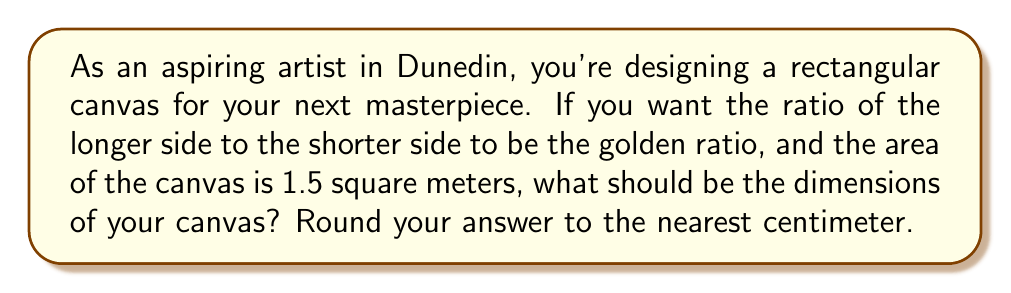Solve this math problem. Let's approach this step-by-step:

1) The golden ratio, often denoted by φ (phi), is approximately 1.618034. We'll use this value in our calculations.

2) Let's denote the shorter side of the rectangle as x and the longer side as y.

3) According to the golden ratio, we have:
   $$\frac{y}{x} = φ ≈ 1.618034$$

4) We can express y in terms of x:
   $$y = 1.618034x$$

5) We're given that the area of the canvas is 1.5 square meters. The area of a rectangle is length times width, so:
   $$xy = 1.5$$

6) Substituting the expression for y:
   $$x(1.618034x) = 1.5$$
   $$1.618034x^2 = 1.5$$

7) Solving for x:
   $$x^2 = \frac{1.5}{1.618034} ≈ 0.927178$$
   $$x ≈ \sqrt{0.927178} ≈ 0.962900$$

8) Now we can calculate y:
   $$y = 1.618034x ≈ 1.618034 * 0.962900 ≈ 1.558010$$

9) Converting to centimeters and rounding to the nearest cm:
   x ≈ 96 cm
   y ≈ 156 cm

Therefore, the dimensions of the canvas should be approximately 96 cm by 156 cm.
Answer: 96 cm × 156 cm 